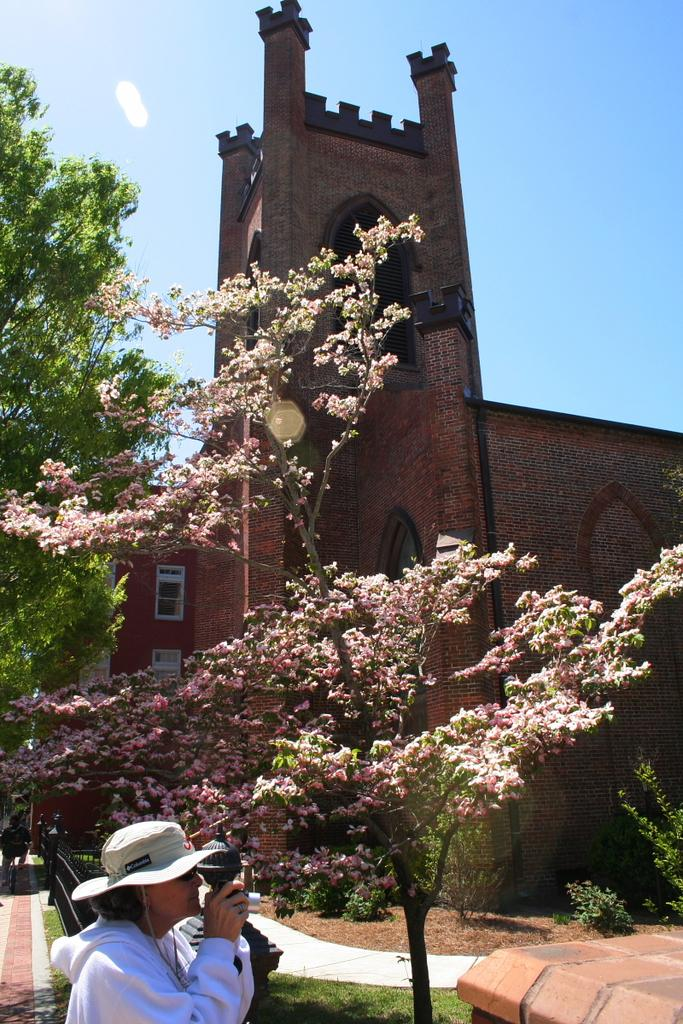Who or what is present in the image? There is a person in the image. What type of natural environment is visible in the image? There are trees and grass in the image. What type of structure can be seen in the image? There is a building in the image. What part of the natural environment is visible in the image? The sky is visible in the image. What type of pot is being used for business purposes in the image? There is no pot present in the image, and no business-related activities are depicted. 